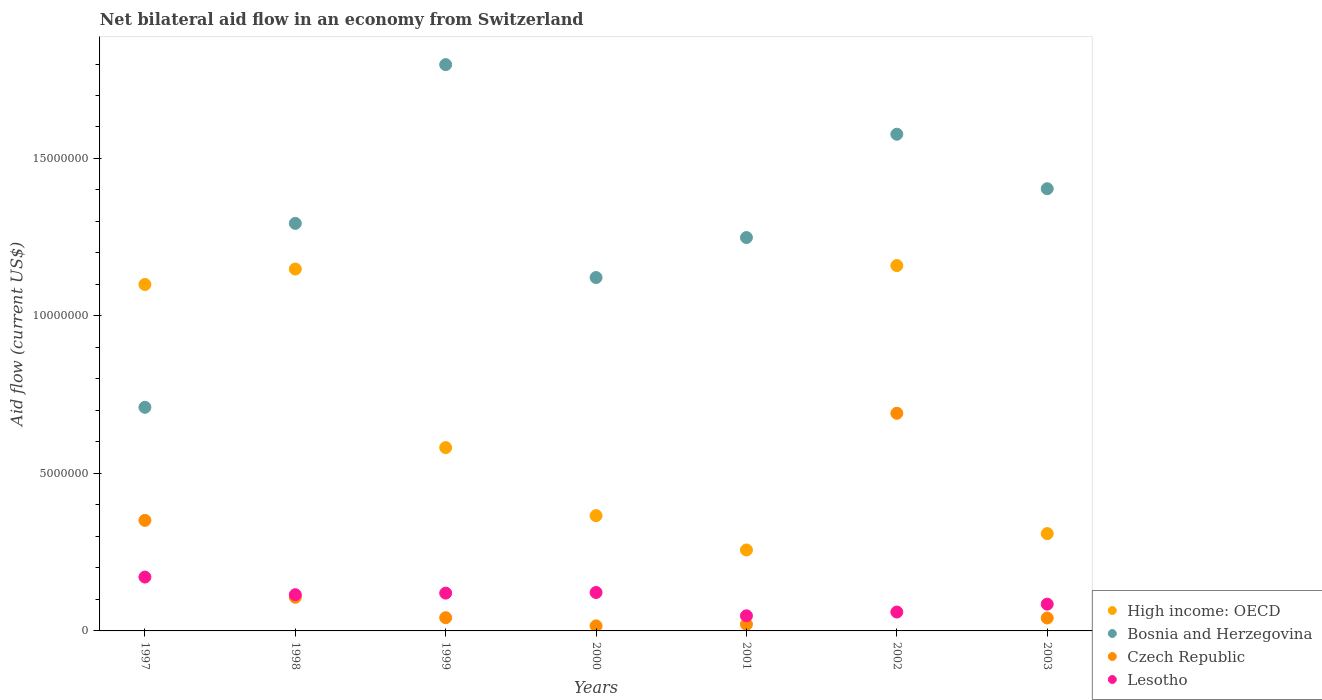How many different coloured dotlines are there?
Offer a very short reply. 4. What is the net bilateral aid flow in Czech Republic in 1998?
Offer a very short reply. 1.07e+06. Across all years, what is the maximum net bilateral aid flow in Bosnia and Herzegovina?
Make the answer very short. 1.80e+07. Across all years, what is the minimum net bilateral aid flow in High income: OECD?
Make the answer very short. 2.57e+06. What is the total net bilateral aid flow in Lesotho in the graph?
Provide a short and direct response. 7.21e+06. What is the difference between the net bilateral aid flow in Lesotho in 1997 and that in 2002?
Your answer should be very brief. 1.11e+06. What is the difference between the net bilateral aid flow in High income: OECD in 2003 and the net bilateral aid flow in Bosnia and Herzegovina in 1999?
Your answer should be very brief. -1.49e+07. What is the average net bilateral aid flow in Bosnia and Herzegovina per year?
Ensure brevity in your answer.  1.31e+07. In the year 2003, what is the difference between the net bilateral aid flow in Czech Republic and net bilateral aid flow in High income: OECD?
Keep it short and to the point. -2.68e+06. In how many years, is the net bilateral aid flow in Czech Republic greater than 11000000 US$?
Give a very brief answer. 0. What is the ratio of the net bilateral aid flow in Lesotho in 2000 to that in 2002?
Your response must be concise. 2.03. Is the net bilateral aid flow in Bosnia and Herzegovina in 1999 less than that in 2002?
Provide a short and direct response. No. What is the difference between the highest and the lowest net bilateral aid flow in High income: OECD?
Your answer should be compact. 9.03e+06. Is the net bilateral aid flow in Czech Republic strictly greater than the net bilateral aid flow in Lesotho over the years?
Ensure brevity in your answer.  No. How many dotlines are there?
Your answer should be compact. 4. Are the values on the major ticks of Y-axis written in scientific E-notation?
Offer a terse response. No. Does the graph contain any zero values?
Ensure brevity in your answer.  No. Where does the legend appear in the graph?
Make the answer very short. Bottom right. How many legend labels are there?
Give a very brief answer. 4. What is the title of the graph?
Your answer should be very brief. Net bilateral aid flow in an economy from Switzerland. What is the Aid flow (current US$) of High income: OECD in 1997?
Your response must be concise. 1.10e+07. What is the Aid flow (current US$) of Bosnia and Herzegovina in 1997?
Provide a short and direct response. 7.10e+06. What is the Aid flow (current US$) in Czech Republic in 1997?
Keep it short and to the point. 3.51e+06. What is the Aid flow (current US$) in Lesotho in 1997?
Give a very brief answer. 1.71e+06. What is the Aid flow (current US$) of High income: OECD in 1998?
Your response must be concise. 1.15e+07. What is the Aid flow (current US$) in Bosnia and Herzegovina in 1998?
Keep it short and to the point. 1.29e+07. What is the Aid flow (current US$) in Czech Republic in 1998?
Ensure brevity in your answer.  1.07e+06. What is the Aid flow (current US$) of Lesotho in 1998?
Make the answer very short. 1.15e+06. What is the Aid flow (current US$) in High income: OECD in 1999?
Provide a short and direct response. 5.82e+06. What is the Aid flow (current US$) in Bosnia and Herzegovina in 1999?
Make the answer very short. 1.80e+07. What is the Aid flow (current US$) in Czech Republic in 1999?
Ensure brevity in your answer.  4.20e+05. What is the Aid flow (current US$) of Lesotho in 1999?
Ensure brevity in your answer.  1.20e+06. What is the Aid flow (current US$) in High income: OECD in 2000?
Provide a short and direct response. 3.66e+06. What is the Aid flow (current US$) of Bosnia and Herzegovina in 2000?
Give a very brief answer. 1.12e+07. What is the Aid flow (current US$) of Czech Republic in 2000?
Your answer should be compact. 1.60e+05. What is the Aid flow (current US$) of Lesotho in 2000?
Give a very brief answer. 1.22e+06. What is the Aid flow (current US$) of High income: OECD in 2001?
Your response must be concise. 2.57e+06. What is the Aid flow (current US$) in Bosnia and Herzegovina in 2001?
Your answer should be compact. 1.25e+07. What is the Aid flow (current US$) of Lesotho in 2001?
Offer a very short reply. 4.80e+05. What is the Aid flow (current US$) of High income: OECD in 2002?
Your answer should be compact. 1.16e+07. What is the Aid flow (current US$) of Bosnia and Herzegovina in 2002?
Your answer should be very brief. 1.58e+07. What is the Aid flow (current US$) in Czech Republic in 2002?
Make the answer very short. 6.91e+06. What is the Aid flow (current US$) of Lesotho in 2002?
Keep it short and to the point. 6.00e+05. What is the Aid flow (current US$) of High income: OECD in 2003?
Your response must be concise. 3.09e+06. What is the Aid flow (current US$) in Bosnia and Herzegovina in 2003?
Give a very brief answer. 1.40e+07. What is the Aid flow (current US$) of Lesotho in 2003?
Your answer should be very brief. 8.50e+05. Across all years, what is the maximum Aid flow (current US$) in High income: OECD?
Offer a very short reply. 1.16e+07. Across all years, what is the maximum Aid flow (current US$) of Bosnia and Herzegovina?
Your response must be concise. 1.80e+07. Across all years, what is the maximum Aid flow (current US$) in Czech Republic?
Keep it short and to the point. 6.91e+06. Across all years, what is the maximum Aid flow (current US$) in Lesotho?
Provide a succinct answer. 1.71e+06. Across all years, what is the minimum Aid flow (current US$) of High income: OECD?
Offer a very short reply. 2.57e+06. Across all years, what is the minimum Aid flow (current US$) of Bosnia and Herzegovina?
Keep it short and to the point. 7.10e+06. What is the total Aid flow (current US$) of High income: OECD in the graph?
Ensure brevity in your answer.  4.92e+07. What is the total Aid flow (current US$) in Bosnia and Herzegovina in the graph?
Your answer should be very brief. 9.15e+07. What is the total Aid flow (current US$) in Czech Republic in the graph?
Your answer should be compact. 1.27e+07. What is the total Aid flow (current US$) in Lesotho in the graph?
Offer a terse response. 7.21e+06. What is the difference between the Aid flow (current US$) of High income: OECD in 1997 and that in 1998?
Ensure brevity in your answer.  -4.90e+05. What is the difference between the Aid flow (current US$) in Bosnia and Herzegovina in 1997 and that in 1998?
Provide a short and direct response. -5.84e+06. What is the difference between the Aid flow (current US$) in Czech Republic in 1997 and that in 1998?
Offer a terse response. 2.44e+06. What is the difference between the Aid flow (current US$) in Lesotho in 1997 and that in 1998?
Your answer should be compact. 5.60e+05. What is the difference between the Aid flow (current US$) of High income: OECD in 1997 and that in 1999?
Give a very brief answer. 5.18e+06. What is the difference between the Aid flow (current US$) in Bosnia and Herzegovina in 1997 and that in 1999?
Provide a short and direct response. -1.09e+07. What is the difference between the Aid flow (current US$) of Czech Republic in 1997 and that in 1999?
Provide a short and direct response. 3.09e+06. What is the difference between the Aid flow (current US$) of Lesotho in 1997 and that in 1999?
Keep it short and to the point. 5.10e+05. What is the difference between the Aid flow (current US$) in High income: OECD in 1997 and that in 2000?
Keep it short and to the point. 7.34e+06. What is the difference between the Aid flow (current US$) in Bosnia and Herzegovina in 1997 and that in 2000?
Offer a very short reply. -4.12e+06. What is the difference between the Aid flow (current US$) of Czech Republic in 1997 and that in 2000?
Make the answer very short. 3.35e+06. What is the difference between the Aid flow (current US$) in High income: OECD in 1997 and that in 2001?
Provide a short and direct response. 8.43e+06. What is the difference between the Aid flow (current US$) in Bosnia and Herzegovina in 1997 and that in 2001?
Provide a short and direct response. -5.39e+06. What is the difference between the Aid flow (current US$) of Czech Republic in 1997 and that in 2001?
Keep it short and to the point. 3.30e+06. What is the difference between the Aid flow (current US$) in Lesotho in 1997 and that in 2001?
Give a very brief answer. 1.23e+06. What is the difference between the Aid flow (current US$) of High income: OECD in 1997 and that in 2002?
Your answer should be very brief. -6.00e+05. What is the difference between the Aid flow (current US$) of Bosnia and Herzegovina in 1997 and that in 2002?
Give a very brief answer. -8.67e+06. What is the difference between the Aid flow (current US$) of Czech Republic in 1997 and that in 2002?
Your response must be concise. -3.40e+06. What is the difference between the Aid flow (current US$) of Lesotho in 1997 and that in 2002?
Offer a very short reply. 1.11e+06. What is the difference between the Aid flow (current US$) of High income: OECD in 1997 and that in 2003?
Your answer should be very brief. 7.91e+06. What is the difference between the Aid flow (current US$) of Bosnia and Herzegovina in 1997 and that in 2003?
Offer a very short reply. -6.94e+06. What is the difference between the Aid flow (current US$) of Czech Republic in 1997 and that in 2003?
Offer a terse response. 3.10e+06. What is the difference between the Aid flow (current US$) in Lesotho in 1997 and that in 2003?
Offer a terse response. 8.60e+05. What is the difference between the Aid flow (current US$) in High income: OECD in 1998 and that in 1999?
Your response must be concise. 5.67e+06. What is the difference between the Aid flow (current US$) in Bosnia and Herzegovina in 1998 and that in 1999?
Offer a terse response. -5.04e+06. What is the difference between the Aid flow (current US$) of Czech Republic in 1998 and that in 1999?
Offer a very short reply. 6.50e+05. What is the difference between the Aid flow (current US$) of High income: OECD in 1998 and that in 2000?
Provide a succinct answer. 7.83e+06. What is the difference between the Aid flow (current US$) in Bosnia and Herzegovina in 1998 and that in 2000?
Keep it short and to the point. 1.72e+06. What is the difference between the Aid flow (current US$) of Czech Republic in 1998 and that in 2000?
Ensure brevity in your answer.  9.10e+05. What is the difference between the Aid flow (current US$) of High income: OECD in 1998 and that in 2001?
Keep it short and to the point. 8.92e+06. What is the difference between the Aid flow (current US$) of Czech Republic in 1998 and that in 2001?
Keep it short and to the point. 8.60e+05. What is the difference between the Aid flow (current US$) of Lesotho in 1998 and that in 2001?
Provide a short and direct response. 6.70e+05. What is the difference between the Aid flow (current US$) in High income: OECD in 1998 and that in 2002?
Offer a very short reply. -1.10e+05. What is the difference between the Aid flow (current US$) of Bosnia and Herzegovina in 1998 and that in 2002?
Provide a succinct answer. -2.83e+06. What is the difference between the Aid flow (current US$) of Czech Republic in 1998 and that in 2002?
Keep it short and to the point. -5.84e+06. What is the difference between the Aid flow (current US$) in High income: OECD in 1998 and that in 2003?
Offer a terse response. 8.40e+06. What is the difference between the Aid flow (current US$) of Bosnia and Herzegovina in 1998 and that in 2003?
Keep it short and to the point. -1.10e+06. What is the difference between the Aid flow (current US$) of High income: OECD in 1999 and that in 2000?
Make the answer very short. 2.16e+06. What is the difference between the Aid flow (current US$) in Bosnia and Herzegovina in 1999 and that in 2000?
Ensure brevity in your answer.  6.76e+06. What is the difference between the Aid flow (current US$) in Czech Republic in 1999 and that in 2000?
Offer a very short reply. 2.60e+05. What is the difference between the Aid flow (current US$) of High income: OECD in 1999 and that in 2001?
Make the answer very short. 3.25e+06. What is the difference between the Aid flow (current US$) of Bosnia and Herzegovina in 1999 and that in 2001?
Offer a very short reply. 5.49e+06. What is the difference between the Aid flow (current US$) of Lesotho in 1999 and that in 2001?
Offer a terse response. 7.20e+05. What is the difference between the Aid flow (current US$) in High income: OECD in 1999 and that in 2002?
Give a very brief answer. -5.78e+06. What is the difference between the Aid flow (current US$) of Bosnia and Herzegovina in 1999 and that in 2002?
Your answer should be very brief. 2.21e+06. What is the difference between the Aid flow (current US$) of Czech Republic in 1999 and that in 2002?
Make the answer very short. -6.49e+06. What is the difference between the Aid flow (current US$) of Lesotho in 1999 and that in 2002?
Keep it short and to the point. 6.00e+05. What is the difference between the Aid flow (current US$) of High income: OECD in 1999 and that in 2003?
Offer a very short reply. 2.73e+06. What is the difference between the Aid flow (current US$) in Bosnia and Herzegovina in 1999 and that in 2003?
Your response must be concise. 3.94e+06. What is the difference between the Aid flow (current US$) in High income: OECD in 2000 and that in 2001?
Give a very brief answer. 1.09e+06. What is the difference between the Aid flow (current US$) of Bosnia and Herzegovina in 2000 and that in 2001?
Make the answer very short. -1.27e+06. What is the difference between the Aid flow (current US$) in Lesotho in 2000 and that in 2001?
Ensure brevity in your answer.  7.40e+05. What is the difference between the Aid flow (current US$) in High income: OECD in 2000 and that in 2002?
Provide a succinct answer. -7.94e+06. What is the difference between the Aid flow (current US$) in Bosnia and Herzegovina in 2000 and that in 2002?
Your answer should be very brief. -4.55e+06. What is the difference between the Aid flow (current US$) of Czech Republic in 2000 and that in 2002?
Give a very brief answer. -6.75e+06. What is the difference between the Aid flow (current US$) in Lesotho in 2000 and that in 2002?
Provide a short and direct response. 6.20e+05. What is the difference between the Aid flow (current US$) in High income: OECD in 2000 and that in 2003?
Provide a succinct answer. 5.70e+05. What is the difference between the Aid flow (current US$) of Bosnia and Herzegovina in 2000 and that in 2003?
Give a very brief answer. -2.82e+06. What is the difference between the Aid flow (current US$) in Lesotho in 2000 and that in 2003?
Your answer should be compact. 3.70e+05. What is the difference between the Aid flow (current US$) in High income: OECD in 2001 and that in 2002?
Your answer should be very brief. -9.03e+06. What is the difference between the Aid flow (current US$) of Bosnia and Herzegovina in 2001 and that in 2002?
Your answer should be very brief. -3.28e+06. What is the difference between the Aid flow (current US$) of Czech Republic in 2001 and that in 2002?
Your answer should be compact. -6.70e+06. What is the difference between the Aid flow (current US$) of Lesotho in 2001 and that in 2002?
Make the answer very short. -1.20e+05. What is the difference between the Aid flow (current US$) of High income: OECD in 2001 and that in 2003?
Ensure brevity in your answer.  -5.20e+05. What is the difference between the Aid flow (current US$) of Bosnia and Herzegovina in 2001 and that in 2003?
Ensure brevity in your answer.  -1.55e+06. What is the difference between the Aid flow (current US$) in Lesotho in 2001 and that in 2003?
Make the answer very short. -3.70e+05. What is the difference between the Aid flow (current US$) of High income: OECD in 2002 and that in 2003?
Your answer should be compact. 8.51e+06. What is the difference between the Aid flow (current US$) in Bosnia and Herzegovina in 2002 and that in 2003?
Ensure brevity in your answer.  1.73e+06. What is the difference between the Aid flow (current US$) of Czech Republic in 2002 and that in 2003?
Provide a short and direct response. 6.50e+06. What is the difference between the Aid flow (current US$) in High income: OECD in 1997 and the Aid flow (current US$) in Bosnia and Herzegovina in 1998?
Give a very brief answer. -1.94e+06. What is the difference between the Aid flow (current US$) of High income: OECD in 1997 and the Aid flow (current US$) of Czech Republic in 1998?
Your answer should be compact. 9.93e+06. What is the difference between the Aid flow (current US$) in High income: OECD in 1997 and the Aid flow (current US$) in Lesotho in 1998?
Provide a short and direct response. 9.85e+06. What is the difference between the Aid flow (current US$) of Bosnia and Herzegovina in 1997 and the Aid flow (current US$) of Czech Republic in 1998?
Make the answer very short. 6.03e+06. What is the difference between the Aid flow (current US$) of Bosnia and Herzegovina in 1997 and the Aid flow (current US$) of Lesotho in 1998?
Your answer should be compact. 5.95e+06. What is the difference between the Aid flow (current US$) in Czech Republic in 1997 and the Aid flow (current US$) in Lesotho in 1998?
Provide a succinct answer. 2.36e+06. What is the difference between the Aid flow (current US$) in High income: OECD in 1997 and the Aid flow (current US$) in Bosnia and Herzegovina in 1999?
Ensure brevity in your answer.  -6.98e+06. What is the difference between the Aid flow (current US$) of High income: OECD in 1997 and the Aid flow (current US$) of Czech Republic in 1999?
Provide a short and direct response. 1.06e+07. What is the difference between the Aid flow (current US$) in High income: OECD in 1997 and the Aid flow (current US$) in Lesotho in 1999?
Make the answer very short. 9.80e+06. What is the difference between the Aid flow (current US$) of Bosnia and Herzegovina in 1997 and the Aid flow (current US$) of Czech Republic in 1999?
Make the answer very short. 6.68e+06. What is the difference between the Aid flow (current US$) in Bosnia and Herzegovina in 1997 and the Aid flow (current US$) in Lesotho in 1999?
Your response must be concise. 5.90e+06. What is the difference between the Aid flow (current US$) of Czech Republic in 1997 and the Aid flow (current US$) of Lesotho in 1999?
Ensure brevity in your answer.  2.31e+06. What is the difference between the Aid flow (current US$) in High income: OECD in 1997 and the Aid flow (current US$) in Czech Republic in 2000?
Your answer should be very brief. 1.08e+07. What is the difference between the Aid flow (current US$) in High income: OECD in 1997 and the Aid flow (current US$) in Lesotho in 2000?
Make the answer very short. 9.78e+06. What is the difference between the Aid flow (current US$) of Bosnia and Herzegovina in 1997 and the Aid flow (current US$) of Czech Republic in 2000?
Give a very brief answer. 6.94e+06. What is the difference between the Aid flow (current US$) of Bosnia and Herzegovina in 1997 and the Aid flow (current US$) of Lesotho in 2000?
Provide a short and direct response. 5.88e+06. What is the difference between the Aid flow (current US$) in Czech Republic in 1997 and the Aid flow (current US$) in Lesotho in 2000?
Keep it short and to the point. 2.29e+06. What is the difference between the Aid flow (current US$) of High income: OECD in 1997 and the Aid flow (current US$) of Bosnia and Herzegovina in 2001?
Your response must be concise. -1.49e+06. What is the difference between the Aid flow (current US$) of High income: OECD in 1997 and the Aid flow (current US$) of Czech Republic in 2001?
Ensure brevity in your answer.  1.08e+07. What is the difference between the Aid flow (current US$) of High income: OECD in 1997 and the Aid flow (current US$) of Lesotho in 2001?
Your answer should be compact. 1.05e+07. What is the difference between the Aid flow (current US$) of Bosnia and Herzegovina in 1997 and the Aid flow (current US$) of Czech Republic in 2001?
Make the answer very short. 6.89e+06. What is the difference between the Aid flow (current US$) of Bosnia and Herzegovina in 1997 and the Aid flow (current US$) of Lesotho in 2001?
Your answer should be compact. 6.62e+06. What is the difference between the Aid flow (current US$) in Czech Republic in 1997 and the Aid flow (current US$) in Lesotho in 2001?
Provide a succinct answer. 3.03e+06. What is the difference between the Aid flow (current US$) of High income: OECD in 1997 and the Aid flow (current US$) of Bosnia and Herzegovina in 2002?
Offer a terse response. -4.77e+06. What is the difference between the Aid flow (current US$) in High income: OECD in 1997 and the Aid flow (current US$) in Czech Republic in 2002?
Your answer should be very brief. 4.09e+06. What is the difference between the Aid flow (current US$) in High income: OECD in 1997 and the Aid flow (current US$) in Lesotho in 2002?
Offer a terse response. 1.04e+07. What is the difference between the Aid flow (current US$) of Bosnia and Herzegovina in 1997 and the Aid flow (current US$) of Lesotho in 2002?
Your response must be concise. 6.50e+06. What is the difference between the Aid flow (current US$) of Czech Republic in 1997 and the Aid flow (current US$) of Lesotho in 2002?
Your response must be concise. 2.91e+06. What is the difference between the Aid flow (current US$) of High income: OECD in 1997 and the Aid flow (current US$) of Bosnia and Herzegovina in 2003?
Your response must be concise. -3.04e+06. What is the difference between the Aid flow (current US$) of High income: OECD in 1997 and the Aid flow (current US$) of Czech Republic in 2003?
Your answer should be very brief. 1.06e+07. What is the difference between the Aid flow (current US$) in High income: OECD in 1997 and the Aid flow (current US$) in Lesotho in 2003?
Offer a very short reply. 1.02e+07. What is the difference between the Aid flow (current US$) of Bosnia and Herzegovina in 1997 and the Aid flow (current US$) of Czech Republic in 2003?
Offer a very short reply. 6.69e+06. What is the difference between the Aid flow (current US$) in Bosnia and Herzegovina in 1997 and the Aid flow (current US$) in Lesotho in 2003?
Provide a succinct answer. 6.25e+06. What is the difference between the Aid flow (current US$) of Czech Republic in 1997 and the Aid flow (current US$) of Lesotho in 2003?
Your response must be concise. 2.66e+06. What is the difference between the Aid flow (current US$) of High income: OECD in 1998 and the Aid flow (current US$) of Bosnia and Herzegovina in 1999?
Your answer should be very brief. -6.49e+06. What is the difference between the Aid flow (current US$) of High income: OECD in 1998 and the Aid flow (current US$) of Czech Republic in 1999?
Your answer should be compact. 1.11e+07. What is the difference between the Aid flow (current US$) of High income: OECD in 1998 and the Aid flow (current US$) of Lesotho in 1999?
Your answer should be very brief. 1.03e+07. What is the difference between the Aid flow (current US$) in Bosnia and Herzegovina in 1998 and the Aid flow (current US$) in Czech Republic in 1999?
Ensure brevity in your answer.  1.25e+07. What is the difference between the Aid flow (current US$) of Bosnia and Herzegovina in 1998 and the Aid flow (current US$) of Lesotho in 1999?
Offer a terse response. 1.17e+07. What is the difference between the Aid flow (current US$) in High income: OECD in 1998 and the Aid flow (current US$) in Czech Republic in 2000?
Make the answer very short. 1.13e+07. What is the difference between the Aid flow (current US$) in High income: OECD in 1998 and the Aid flow (current US$) in Lesotho in 2000?
Keep it short and to the point. 1.03e+07. What is the difference between the Aid flow (current US$) of Bosnia and Herzegovina in 1998 and the Aid flow (current US$) of Czech Republic in 2000?
Your answer should be compact. 1.28e+07. What is the difference between the Aid flow (current US$) of Bosnia and Herzegovina in 1998 and the Aid flow (current US$) of Lesotho in 2000?
Your answer should be compact. 1.17e+07. What is the difference between the Aid flow (current US$) in Czech Republic in 1998 and the Aid flow (current US$) in Lesotho in 2000?
Provide a succinct answer. -1.50e+05. What is the difference between the Aid flow (current US$) of High income: OECD in 1998 and the Aid flow (current US$) of Bosnia and Herzegovina in 2001?
Offer a terse response. -1.00e+06. What is the difference between the Aid flow (current US$) of High income: OECD in 1998 and the Aid flow (current US$) of Czech Republic in 2001?
Your answer should be compact. 1.13e+07. What is the difference between the Aid flow (current US$) of High income: OECD in 1998 and the Aid flow (current US$) of Lesotho in 2001?
Make the answer very short. 1.10e+07. What is the difference between the Aid flow (current US$) in Bosnia and Herzegovina in 1998 and the Aid flow (current US$) in Czech Republic in 2001?
Make the answer very short. 1.27e+07. What is the difference between the Aid flow (current US$) of Bosnia and Herzegovina in 1998 and the Aid flow (current US$) of Lesotho in 2001?
Offer a terse response. 1.25e+07. What is the difference between the Aid flow (current US$) in Czech Republic in 1998 and the Aid flow (current US$) in Lesotho in 2001?
Make the answer very short. 5.90e+05. What is the difference between the Aid flow (current US$) of High income: OECD in 1998 and the Aid flow (current US$) of Bosnia and Herzegovina in 2002?
Offer a terse response. -4.28e+06. What is the difference between the Aid flow (current US$) in High income: OECD in 1998 and the Aid flow (current US$) in Czech Republic in 2002?
Your answer should be compact. 4.58e+06. What is the difference between the Aid flow (current US$) in High income: OECD in 1998 and the Aid flow (current US$) in Lesotho in 2002?
Your answer should be compact. 1.09e+07. What is the difference between the Aid flow (current US$) in Bosnia and Herzegovina in 1998 and the Aid flow (current US$) in Czech Republic in 2002?
Ensure brevity in your answer.  6.03e+06. What is the difference between the Aid flow (current US$) in Bosnia and Herzegovina in 1998 and the Aid flow (current US$) in Lesotho in 2002?
Offer a terse response. 1.23e+07. What is the difference between the Aid flow (current US$) in High income: OECD in 1998 and the Aid flow (current US$) in Bosnia and Herzegovina in 2003?
Keep it short and to the point. -2.55e+06. What is the difference between the Aid flow (current US$) in High income: OECD in 1998 and the Aid flow (current US$) in Czech Republic in 2003?
Keep it short and to the point. 1.11e+07. What is the difference between the Aid flow (current US$) of High income: OECD in 1998 and the Aid flow (current US$) of Lesotho in 2003?
Your answer should be very brief. 1.06e+07. What is the difference between the Aid flow (current US$) of Bosnia and Herzegovina in 1998 and the Aid flow (current US$) of Czech Republic in 2003?
Make the answer very short. 1.25e+07. What is the difference between the Aid flow (current US$) of Bosnia and Herzegovina in 1998 and the Aid flow (current US$) of Lesotho in 2003?
Make the answer very short. 1.21e+07. What is the difference between the Aid flow (current US$) of High income: OECD in 1999 and the Aid flow (current US$) of Bosnia and Herzegovina in 2000?
Offer a very short reply. -5.40e+06. What is the difference between the Aid flow (current US$) in High income: OECD in 1999 and the Aid flow (current US$) in Czech Republic in 2000?
Provide a succinct answer. 5.66e+06. What is the difference between the Aid flow (current US$) of High income: OECD in 1999 and the Aid flow (current US$) of Lesotho in 2000?
Your answer should be compact. 4.60e+06. What is the difference between the Aid flow (current US$) in Bosnia and Herzegovina in 1999 and the Aid flow (current US$) in Czech Republic in 2000?
Offer a terse response. 1.78e+07. What is the difference between the Aid flow (current US$) in Bosnia and Herzegovina in 1999 and the Aid flow (current US$) in Lesotho in 2000?
Provide a short and direct response. 1.68e+07. What is the difference between the Aid flow (current US$) in Czech Republic in 1999 and the Aid flow (current US$) in Lesotho in 2000?
Provide a short and direct response. -8.00e+05. What is the difference between the Aid flow (current US$) in High income: OECD in 1999 and the Aid flow (current US$) in Bosnia and Herzegovina in 2001?
Offer a very short reply. -6.67e+06. What is the difference between the Aid flow (current US$) of High income: OECD in 1999 and the Aid flow (current US$) of Czech Republic in 2001?
Provide a short and direct response. 5.61e+06. What is the difference between the Aid flow (current US$) of High income: OECD in 1999 and the Aid flow (current US$) of Lesotho in 2001?
Provide a succinct answer. 5.34e+06. What is the difference between the Aid flow (current US$) in Bosnia and Herzegovina in 1999 and the Aid flow (current US$) in Czech Republic in 2001?
Provide a short and direct response. 1.78e+07. What is the difference between the Aid flow (current US$) in Bosnia and Herzegovina in 1999 and the Aid flow (current US$) in Lesotho in 2001?
Make the answer very short. 1.75e+07. What is the difference between the Aid flow (current US$) of High income: OECD in 1999 and the Aid flow (current US$) of Bosnia and Herzegovina in 2002?
Give a very brief answer. -9.95e+06. What is the difference between the Aid flow (current US$) of High income: OECD in 1999 and the Aid flow (current US$) of Czech Republic in 2002?
Ensure brevity in your answer.  -1.09e+06. What is the difference between the Aid flow (current US$) in High income: OECD in 1999 and the Aid flow (current US$) in Lesotho in 2002?
Provide a short and direct response. 5.22e+06. What is the difference between the Aid flow (current US$) in Bosnia and Herzegovina in 1999 and the Aid flow (current US$) in Czech Republic in 2002?
Ensure brevity in your answer.  1.11e+07. What is the difference between the Aid flow (current US$) of Bosnia and Herzegovina in 1999 and the Aid flow (current US$) of Lesotho in 2002?
Keep it short and to the point. 1.74e+07. What is the difference between the Aid flow (current US$) of Czech Republic in 1999 and the Aid flow (current US$) of Lesotho in 2002?
Offer a very short reply. -1.80e+05. What is the difference between the Aid flow (current US$) in High income: OECD in 1999 and the Aid flow (current US$) in Bosnia and Herzegovina in 2003?
Offer a terse response. -8.22e+06. What is the difference between the Aid flow (current US$) of High income: OECD in 1999 and the Aid flow (current US$) of Czech Republic in 2003?
Provide a short and direct response. 5.41e+06. What is the difference between the Aid flow (current US$) in High income: OECD in 1999 and the Aid flow (current US$) in Lesotho in 2003?
Provide a short and direct response. 4.97e+06. What is the difference between the Aid flow (current US$) in Bosnia and Herzegovina in 1999 and the Aid flow (current US$) in Czech Republic in 2003?
Offer a very short reply. 1.76e+07. What is the difference between the Aid flow (current US$) in Bosnia and Herzegovina in 1999 and the Aid flow (current US$) in Lesotho in 2003?
Offer a very short reply. 1.71e+07. What is the difference between the Aid flow (current US$) in Czech Republic in 1999 and the Aid flow (current US$) in Lesotho in 2003?
Keep it short and to the point. -4.30e+05. What is the difference between the Aid flow (current US$) of High income: OECD in 2000 and the Aid flow (current US$) of Bosnia and Herzegovina in 2001?
Your answer should be compact. -8.83e+06. What is the difference between the Aid flow (current US$) in High income: OECD in 2000 and the Aid flow (current US$) in Czech Republic in 2001?
Your response must be concise. 3.45e+06. What is the difference between the Aid flow (current US$) of High income: OECD in 2000 and the Aid flow (current US$) of Lesotho in 2001?
Offer a very short reply. 3.18e+06. What is the difference between the Aid flow (current US$) of Bosnia and Herzegovina in 2000 and the Aid flow (current US$) of Czech Republic in 2001?
Your response must be concise. 1.10e+07. What is the difference between the Aid flow (current US$) in Bosnia and Herzegovina in 2000 and the Aid flow (current US$) in Lesotho in 2001?
Your response must be concise. 1.07e+07. What is the difference between the Aid flow (current US$) in Czech Republic in 2000 and the Aid flow (current US$) in Lesotho in 2001?
Make the answer very short. -3.20e+05. What is the difference between the Aid flow (current US$) of High income: OECD in 2000 and the Aid flow (current US$) of Bosnia and Herzegovina in 2002?
Your answer should be very brief. -1.21e+07. What is the difference between the Aid flow (current US$) of High income: OECD in 2000 and the Aid flow (current US$) of Czech Republic in 2002?
Your answer should be compact. -3.25e+06. What is the difference between the Aid flow (current US$) in High income: OECD in 2000 and the Aid flow (current US$) in Lesotho in 2002?
Your answer should be compact. 3.06e+06. What is the difference between the Aid flow (current US$) of Bosnia and Herzegovina in 2000 and the Aid flow (current US$) of Czech Republic in 2002?
Give a very brief answer. 4.31e+06. What is the difference between the Aid flow (current US$) in Bosnia and Herzegovina in 2000 and the Aid flow (current US$) in Lesotho in 2002?
Your answer should be compact. 1.06e+07. What is the difference between the Aid flow (current US$) in Czech Republic in 2000 and the Aid flow (current US$) in Lesotho in 2002?
Ensure brevity in your answer.  -4.40e+05. What is the difference between the Aid flow (current US$) in High income: OECD in 2000 and the Aid flow (current US$) in Bosnia and Herzegovina in 2003?
Make the answer very short. -1.04e+07. What is the difference between the Aid flow (current US$) of High income: OECD in 2000 and the Aid flow (current US$) of Czech Republic in 2003?
Offer a very short reply. 3.25e+06. What is the difference between the Aid flow (current US$) of High income: OECD in 2000 and the Aid flow (current US$) of Lesotho in 2003?
Offer a terse response. 2.81e+06. What is the difference between the Aid flow (current US$) of Bosnia and Herzegovina in 2000 and the Aid flow (current US$) of Czech Republic in 2003?
Your response must be concise. 1.08e+07. What is the difference between the Aid flow (current US$) in Bosnia and Herzegovina in 2000 and the Aid flow (current US$) in Lesotho in 2003?
Keep it short and to the point. 1.04e+07. What is the difference between the Aid flow (current US$) of Czech Republic in 2000 and the Aid flow (current US$) of Lesotho in 2003?
Provide a short and direct response. -6.90e+05. What is the difference between the Aid flow (current US$) in High income: OECD in 2001 and the Aid flow (current US$) in Bosnia and Herzegovina in 2002?
Make the answer very short. -1.32e+07. What is the difference between the Aid flow (current US$) of High income: OECD in 2001 and the Aid flow (current US$) of Czech Republic in 2002?
Offer a terse response. -4.34e+06. What is the difference between the Aid flow (current US$) of High income: OECD in 2001 and the Aid flow (current US$) of Lesotho in 2002?
Make the answer very short. 1.97e+06. What is the difference between the Aid flow (current US$) of Bosnia and Herzegovina in 2001 and the Aid flow (current US$) of Czech Republic in 2002?
Your response must be concise. 5.58e+06. What is the difference between the Aid flow (current US$) in Bosnia and Herzegovina in 2001 and the Aid flow (current US$) in Lesotho in 2002?
Give a very brief answer. 1.19e+07. What is the difference between the Aid flow (current US$) in Czech Republic in 2001 and the Aid flow (current US$) in Lesotho in 2002?
Your answer should be very brief. -3.90e+05. What is the difference between the Aid flow (current US$) of High income: OECD in 2001 and the Aid flow (current US$) of Bosnia and Herzegovina in 2003?
Your answer should be very brief. -1.15e+07. What is the difference between the Aid flow (current US$) of High income: OECD in 2001 and the Aid flow (current US$) of Czech Republic in 2003?
Give a very brief answer. 2.16e+06. What is the difference between the Aid flow (current US$) in High income: OECD in 2001 and the Aid flow (current US$) in Lesotho in 2003?
Provide a succinct answer. 1.72e+06. What is the difference between the Aid flow (current US$) in Bosnia and Herzegovina in 2001 and the Aid flow (current US$) in Czech Republic in 2003?
Keep it short and to the point. 1.21e+07. What is the difference between the Aid flow (current US$) in Bosnia and Herzegovina in 2001 and the Aid flow (current US$) in Lesotho in 2003?
Your answer should be very brief. 1.16e+07. What is the difference between the Aid flow (current US$) in Czech Republic in 2001 and the Aid flow (current US$) in Lesotho in 2003?
Your answer should be compact. -6.40e+05. What is the difference between the Aid flow (current US$) in High income: OECD in 2002 and the Aid flow (current US$) in Bosnia and Herzegovina in 2003?
Offer a terse response. -2.44e+06. What is the difference between the Aid flow (current US$) in High income: OECD in 2002 and the Aid flow (current US$) in Czech Republic in 2003?
Your answer should be very brief. 1.12e+07. What is the difference between the Aid flow (current US$) of High income: OECD in 2002 and the Aid flow (current US$) of Lesotho in 2003?
Give a very brief answer. 1.08e+07. What is the difference between the Aid flow (current US$) of Bosnia and Herzegovina in 2002 and the Aid flow (current US$) of Czech Republic in 2003?
Offer a very short reply. 1.54e+07. What is the difference between the Aid flow (current US$) in Bosnia and Herzegovina in 2002 and the Aid flow (current US$) in Lesotho in 2003?
Make the answer very short. 1.49e+07. What is the difference between the Aid flow (current US$) in Czech Republic in 2002 and the Aid flow (current US$) in Lesotho in 2003?
Offer a very short reply. 6.06e+06. What is the average Aid flow (current US$) in High income: OECD per year?
Ensure brevity in your answer.  7.03e+06. What is the average Aid flow (current US$) of Bosnia and Herzegovina per year?
Give a very brief answer. 1.31e+07. What is the average Aid flow (current US$) of Czech Republic per year?
Ensure brevity in your answer.  1.81e+06. What is the average Aid flow (current US$) of Lesotho per year?
Offer a terse response. 1.03e+06. In the year 1997, what is the difference between the Aid flow (current US$) of High income: OECD and Aid flow (current US$) of Bosnia and Herzegovina?
Keep it short and to the point. 3.90e+06. In the year 1997, what is the difference between the Aid flow (current US$) of High income: OECD and Aid flow (current US$) of Czech Republic?
Ensure brevity in your answer.  7.49e+06. In the year 1997, what is the difference between the Aid flow (current US$) of High income: OECD and Aid flow (current US$) of Lesotho?
Keep it short and to the point. 9.29e+06. In the year 1997, what is the difference between the Aid flow (current US$) in Bosnia and Herzegovina and Aid flow (current US$) in Czech Republic?
Make the answer very short. 3.59e+06. In the year 1997, what is the difference between the Aid flow (current US$) of Bosnia and Herzegovina and Aid flow (current US$) of Lesotho?
Ensure brevity in your answer.  5.39e+06. In the year 1997, what is the difference between the Aid flow (current US$) of Czech Republic and Aid flow (current US$) of Lesotho?
Offer a very short reply. 1.80e+06. In the year 1998, what is the difference between the Aid flow (current US$) of High income: OECD and Aid flow (current US$) of Bosnia and Herzegovina?
Ensure brevity in your answer.  -1.45e+06. In the year 1998, what is the difference between the Aid flow (current US$) of High income: OECD and Aid flow (current US$) of Czech Republic?
Your answer should be very brief. 1.04e+07. In the year 1998, what is the difference between the Aid flow (current US$) in High income: OECD and Aid flow (current US$) in Lesotho?
Offer a terse response. 1.03e+07. In the year 1998, what is the difference between the Aid flow (current US$) in Bosnia and Herzegovina and Aid flow (current US$) in Czech Republic?
Your answer should be compact. 1.19e+07. In the year 1998, what is the difference between the Aid flow (current US$) of Bosnia and Herzegovina and Aid flow (current US$) of Lesotho?
Ensure brevity in your answer.  1.18e+07. In the year 1998, what is the difference between the Aid flow (current US$) of Czech Republic and Aid flow (current US$) of Lesotho?
Your answer should be very brief. -8.00e+04. In the year 1999, what is the difference between the Aid flow (current US$) in High income: OECD and Aid flow (current US$) in Bosnia and Herzegovina?
Your answer should be very brief. -1.22e+07. In the year 1999, what is the difference between the Aid flow (current US$) of High income: OECD and Aid flow (current US$) of Czech Republic?
Your answer should be very brief. 5.40e+06. In the year 1999, what is the difference between the Aid flow (current US$) of High income: OECD and Aid flow (current US$) of Lesotho?
Provide a short and direct response. 4.62e+06. In the year 1999, what is the difference between the Aid flow (current US$) of Bosnia and Herzegovina and Aid flow (current US$) of Czech Republic?
Your answer should be very brief. 1.76e+07. In the year 1999, what is the difference between the Aid flow (current US$) in Bosnia and Herzegovina and Aid flow (current US$) in Lesotho?
Make the answer very short. 1.68e+07. In the year 1999, what is the difference between the Aid flow (current US$) in Czech Republic and Aid flow (current US$) in Lesotho?
Your response must be concise. -7.80e+05. In the year 2000, what is the difference between the Aid flow (current US$) in High income: OECD and Aid flow (current US$) in Bosnia and Herzegovina?
Your answer should be very brief. -7.56e+06. In the year 2000, what is the difference between the Aid flow (current US$) in High income: OECD and Aid flow (current US$) in Czech Republic?
Offer a terse response. 3.50e+06. In the year 2000, what is the difference between the Aid flow (current US$) in High income: OECD and Aid flow (current US$) in Lesotho?
Give a very brief answer. 2.44e+06. In the year 2000, what is the difference between the Aid flow (current US$) in Bosnia and Herzegovina and Aid flow (current US$) in Czech Republic?
Give a very brief answer. 1.11e+07. In the year 2000, what is the difference between the Aid flow (current US$) in Czech Republic and Aid flow (current US$) in Lesotho?
Offer a very short reply. -1.06e+06. In the year 2001, what is the difference between the Aid flow (current US$) of High income: OECD and Aid flow (current US$) of Bosnia and Herzegovina?
Your answer should be compact. -9.92e+06. In the year 2001, what is the difference between the Aid flow (current US$) of High income: OECD and Aid flow (current US$) of Czech Republic?
Offer a very short reply. 2.36e+06. In the year 2001, what is the difference between the Aid flow (current US$) of High income: OECD and Aid flow (current US$) of Lesotho?
Your response must be concise. 2.09e+06. In the year 2001, what is the difference between the Aid flow (current US$) of Bosnia and Herzegovina and Aid flow (current US$) of Czech Republic?
Your response must be concise. 1.23e+07. In the year 2001, what is the difference between the Aid flow (current US$) in Bosnia and Herzegovina and Aid flow (current US$) in Lesotho?
Give a very brief answer. 1.20e+07. In the year 2001, what is the difference between the Aid flow (current US$) of Czech Republic and Aid flow (current US$) of Lesotho?
Your answer should be very brief. -2.70e+05. In the year 2002, what is the difference between the Aid flow (current US$) in High income: OECD and Aid flow (current US$) in Bosnia and Herzegovina?
Provide a succinct answer. -4.17e+06. In the year 2002, what is the difference between the Aid flow (current US$) of High income: OECD and Aid flow (current US$) of Czech Republic?
Make the answer very short. 4.69e+06. In the year 2002, what is the difference between the Aid flow (current US$) of High income: OECD and Aid flow (current US$) of Lesotho?
Your answer should be very brief. 1.10e+07. In the year 2002, what is the difference between the Aid flow (current US$) in Bosnia and Herzegovina and Aid flow (current US$) in Czech Republic?
Offer a very short reply. 8.86e+06. In the year 2002, what is the difference between the Aid flow (current US$) in Bosnia and Herzegovina and Aid flow (current US$) in Lesotho?
Your response must be concise. 1.52e+07. In the year 2002, what is the difference between the Aid flow (current US$) in Czech Republic and Aid flow (current US$) in Lesotho?
Your answer should be very brief. 6.31e+06. In the year 2003, what is the difference between the Aid flow (current US$) of High income: OECD and Aid flow (current US$) of Bosnia and Herzegovina?
Keep it short and to the point. -1.10e+07. In the year 2003, what is the difference between the Aid flow (current US$) in High income: OECD and Aid flow (current US$) in Czech Republic?
Provide a short and direct response. 2.68e+06. In the year 2003, what is the difference between the Aid flow (current US$) of High income: OECD and Aid flow (current US$) of Lesotho?
Your answer should be compact. 2.24e+06. In the year 2003, what is the difference between the Aid flow (current US$) of Bosnia and Herzegovina and Aid flow (current US$) of Czech Republic?
Offer a very short reply. 1.36e+07. In the year 2003, what is the difference between the Aid flow (current US$) in Bosnia and Herzegovina and Aid flow (current US$) in Lesotho?
Keep it short and to the point. 1.32e+07. In the year 2003, what is the difference between the Aid flow (current US$) in Czech Republic and Aid flow (current US$) in Lesotho?
Your response must be concise. -4.40e+05. What is the ratio of the Aid flow (current US$) in High income: OECD in 1997 to that in 1998?
Keep it short and to the point. 0.96. What is the ratio of the Aid flow (current US$) of Bosnia and Herzegovina in 1997 to that in 1998?
Make the answer very short. 0.55. What is the ratio of the Aid flow (current US$) in Czech Republic in 1997 to that in 1998?
Your response must be concise. 3.28. What is the ratio of the Aid flow (current US$) in Lesotho in 1997 to that in 1998?
Offer a terse response. 1.49. What is the ratio of the Aid flow (current US$) of High income: OECD in 1997 to that in 1999?
Give a very brief answer. 1.89. What is the ratio of the Aid flow (current US$) in Bosnia and Herzegovina in 1997 to that in 1999?
Offer a very short reply. 0.39. What is the ratio of the Aid flow (current US$) in Czech Republic in 1997 to that in 1999?
Your answer should be very brief. 8.36. What is the ratio of the Aid flow (current US$) of Lesotho in 1997 to that in 1999?
Your response must be concise. 1.43. What is the ratio of the Aid flow (current US$) in High income: OECD in 1997 to that in 2000?
Provide a short and direct response. 3.01. What is the ratio of the Aid flow (current US$) in Bosnia and Herzegovina in 1997 to that in 2000?
Give a very brief answer. 0.63. What is the ratio of the Aid flow (current US$) of Czech Republic in 1997 to that in 2000?
Keep it short and to the point. 21.94. What is the ratio of the Aid flow (current US$) in Lesotho in 1997 to that in 2000?
Your answer should be very brief. 1.4. What is the ratio of the Aid flow (current US$) of High income: OECD in 1997 to that in 2001?
Your answer should be compact. 4.28. What is the ratio of the Aid flow (current US$) of Bosnia and Herzegovina in 1997 to that in 2001?
Give a very brief answer. 0.57. What is the ratio of the Aid flow (current US$) in Czech Republic in 1997 to that in 2001?
Your response must be concise. 16.71. What is the ratio of the Aid flow (current US$) in Lesotho in 1997 to that in 2001?
Provide a succinct answer. 3.56. What is the ratio of the Aid flow (current US$) in High income: OECD in 1997 to that in 2002?
Offer a terse response. 0.95. What is the ratio of the Aid flow (current US$) of Bosnia and Herzegovina in 1997 to that in 2002?
Your response must be concise. 0.45. What is the ratio of the Aid flow (current US$) in Czech Republic in 1997 to that in 2002?
Give a very brief answer. 0.51. What is the ratio of the Aid flow (current US$) of Lesotho in 1997 to that in 2002?
Keep it short and to the point. 2.85. What is the ratio of the Aid flow (current US$) in High income: OECD in 1997 to that in 2003?
Your answer should be compact. 3.56. What is the ratio of the Aid flow (current US$) of Bosnia and Herzegovina in 1997 to that in 2003?
Provide a short and direct response. 0.51. What is the ratio of the Aid flow (current US$) of Czech Republic in 1997 to that in 2003?
Your answer should be compact. 8.56. What is the ratio of the Aid flow (current US$) in Lesotho in 1997 to that in 2003?
Provide a succinct answer. 2.01. What is the ratio of the Aid flow (current US$) of High income: OECD in 1998 to that in 1999?
Provide a short and direct response. 1.97. What is the ratio of the Aid flow (current US$) in Bosnia and Herzegovina in 1998 to that in 1999?
Your answer should be very brief. 0.72. What is the ratio of the Aid flow (current US$) in Czech Republic in 1998 to that in 1999?
Your answer should be compact. 2.55. What is the ratio of the Aid flow (current US$) in High income: OECD in 1998 to that in 2000?
Make the answer very short. 3.14. What is the ratio of the Aid flow (current US$) in Bosnia and Herzegovina in 1998 to that in 2000?
Keep it short and to the point. 1.15. What is the ratio of the Aid flow (current US$) in Czech Republic in 1998 to that in 2000?
Offer a terse response. 6.69. What is the ratio of the Aid flow (current US$) in Lesotho in 1998 to that in 2000?
Offer a very short reply. 0.94. What is the ratio of the Aid flow (current US$) in High income: OECD in 1998 to that in 2001?
Provide a succinct answer. 4.47. What is the ratio of the Aid flow (current US$) of Bosnia and Herzegovina in 1998 to that in 2001?
Offer a very short reply. 1.04. What is the ratio of the Aid flow (current US$) of Czech Republic in 1998 to that in 2001?
Ensure brevity in your answer.  5.1. What is the ratio of the Aid flow (current US$) of Lesotho in 1998 to that in 2001?
Offer a very short reply. 2.4. What is the ratio of the Aid flow (current US$) of High income: OECD in 1998 to that in 2002?
Your response must be concise. 0.99. What is the ratio of the Aid flow (current US$) of Bosnia and Herzegovina in 1998 to that in 2002?
Keep it short and to the point. 0.82. What is the ratio of the Aid flow (current US$) of Czech Republic in 1998 to that in 2002?
Give a very brief answer. 0.15. What is the ratio of the Aid flow (current US$) in Lesotho in 1998 to that in 2002?
Keep it short and to the point. 1.92. What is the ratio of the Aid flow (current US$) in High income: OECD in 1998 to that in 2003?
Keep it short and to the point. 3.72. What is the ratio of the Aid flow (current US$) of Bosnia and Herzegovina in 1998 to that in 2003?
Make the answer very short. 0.92. What is the ratio of the Aid flow (current US$) of Czech Republic in 1998 to that in 2003?
Provide a succinct answer. 2.61. What is the ratio of the Aid flow (current US$) in Lesotho in 1998 to that in 2003?
Ensure brevity in your answer.  1.35. What is the ratio of the Aid flow (current US$) of High income: OECD in 1999 to that in 2000?
Keep it short and to the point. 1.59. What is the ratio of the Aid flow (current US$) of Bosnia and Herzegovina in 1999 to that in 2000?
Your answer should be very brief. 1.6. What is the ratio of the Aid flow (current US$) of Czech Republic in 1999 to that in 2000?
Ensure brevity in your answer.  2.62. What is the ratio of the Aid flow (current US$) in Lesotho in 1999 to that in 2000?
Provide a succinct answer. 0.98. What is the ratio of the Aid flow (current US$) of High income: OECD in 1999 to that in 2001?
Make the answer very short. 2.26. What is the ratio of the Aid flow (current US$) in Bosnia and Herzegovina in 1999 to that in 2001?
Provide a short and direct response. 1.44. What is the ratio of the Aid flow (current US$) of Lesotho in 1999 to that in 2001?
Provide a succinct answer. 2.5. What is the ratio of the Aid flow (current US$) of High income: OECD in 1999 to that in 2002?
Offer a very short reply. 0.5. What is the ratio of the Aid flow (current US$) of Bosnia and Herzegovina in 1999 to that in 2002?
Keep it short and to the point. 1.14. What is the ratio of the Aid flow (current US$) in Czech Republic in 1999 to that in 2002?
Provide a succinct answer. 0.06. What is the ratio of the Aid flow (current US$) in High income: OECD in 1999 to that in 2003?
Your response must be concise. 1.88. What is the ratio of the Aid flow (current US$) in Bosnia and Herzegovina in 1999 to that in 2003?
Offer a very short reply. 1.28. What is the ratio of the Aid flow (current US$) of Czech Republic in 1999 to that in 2003?
Give a very brief answer. 1.02. What is the ratio of the Aid flow (current US$) of Lesotho in 1999 to that in 2003?
Offer a very short reply. 1.41. What is the ratio of the Aid flow (current US$) of High income: OECD in 2000 to that in 2001?
Your answer should be very brief. 1.42. What is the ratio of the Aid flow (current US$) in Bosnia and Herzegovina in 2000 to that in 2001?
Make the answer very short. 0.9. What is the ratio of the Aid flow (current US$) of Czech Republic in 2000 to that in 2001?
Provide a short and direct response. 0.76. What is the ratio of the Aid flow (current US$) in Lesotho in 2000 to that in 2001?
Make the answer very short. 2.54. What is the ratio of the Aid flow (current US$) in High income: OECD in 2000 to that in 2002?
Give a very brief answer. 0.32. What is the ratio of the Aid flow (current US$) in Bosnia and Herzegovina in 2000 to that in 2002?
Ensure brevity in your answer.  0.71. What is the ratio of the Aid flow (current US$) of Czech Republic in 2000 to that in 2002?
Your response must be concise. 0.02. What is the ratio of the Aid flow (current US$) in Lesotho in 2000 to that in 2002?
Keep it short and to the point. 2.03. What is the ratio of the Aid flow (current US$) of High income: OECD in 2000 to that in 2003?
Your response must be concise. 1.18. What is the ratio of the Aid flow (current US$) in Bosnia and Herzegovina in 2000 to that in 2003?
Your response must be concise. 0.8. What is the ratio of the Aid flow (current US$) of Czech Republic in 2000 to that in 2003?
Your answer should be compact. 0.39. What is the ratio of the Aid flow (current US$) of Lesotho in 2000 to that in 2003?
Your response must be concise. 1.44. What is the ratio of the Aid flow (current US$) of High income: OECD in 2001 to that in 2002?
Make the answer very short. 0.22. What is the ratio of the Aid flow (current US$) of Bosnia and Herzegovina in 2001 to that in 2002?
Keep it short and to the point. 0.79. What is the ratio of the Aid flow (current US$) in Czech Republic in 2001 to that in 2002?
Keep it short and to the point. 0.03. What is the ratio of the Aid flow (current US$) of High income: OECD in 2001 to that in 2003?
Give a very brief answer. 0.83. What is the ratio of the Aid flow (current US$) in Bosnia and Herzegovina in 2001 to that in 2003?
Provide a succinct answer. 0.89. What is the ratio of the Aid flow (current US$) of Czech Republic in 2001 to that in 2003?
Give a very brief answer. 0.51. What is the ratio of the Aid flow (current US$) in Lesotho in 2001 to that in 2003?
Offer a terse response. 0.56. What is the ratio of the Aid flow (current US$) in High income: OECD in 2002 to that in 2003?
Provide a short and direct response. 3.75. What is the ratio of the Aid flow (current US$) in Bosnia and Herzegovina in 2002 to that in 2003?
Keep it short and to the point. 1.12. What is the ratio of the Aid flow (current US$) in Czech Republic in 2002 to that in 2003?
Your answer should be compact. 16.85. What is the ratio of the Aid flow (current US$) in Lesotho in 2002 to that in 2003?
Your answer should be compact. 0.71. What is the difference between the highest and the second highest Aid flow (current US$) of High income: OECD?
Offer a very short reply. 1.10e+05. What is the difference between the highest and the second highest Aid flow (current US$) of Bosnia and Herzegovina?
Offer a very short reply. 2.21e+06. What is the difference between the highest and the second highest Aid flow (current US$) of Czech Republic?
Ensure brevity in your answer.  3.40e+06. What is the difference between the highest and the lowest Aid flow (current US$) in High income: OECD?
Keep it short and to the point. 9.03e+06. What is the difference between the highest and the lowest Aid flow (current US$) of Bosnia and Herzegovina?
Your answer should be very brief. 1.09e+07. What is the difference between the highest and the lowest Aid flow (current US$) of Czech Republic?
Give a very brief answer. 6.75e+06. What is the difference between the highest and the lowest Aid flow (current US$) in Lesotho?
Ensure brevity in your answer.  1.23e+06. 